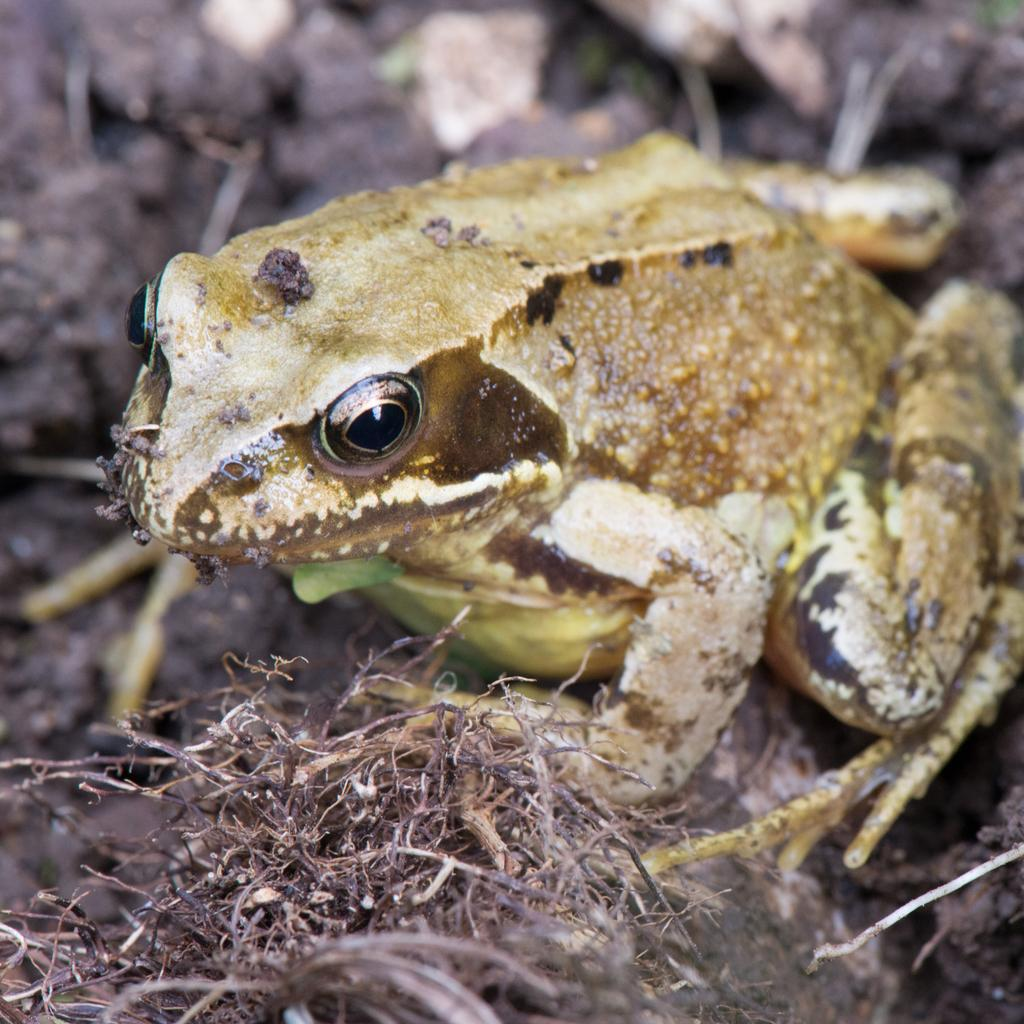What animal is present in the image? There is a frog in the image. Where is the frog located? The frog is on the ground. What type of vegetation can be seen in the image? There is dried grass in the image. Can you describe the background of the image? The background of the image is blurry. What is the ghost's reaction to the frog in the image? There is no ghost present in the image, so it is not possible to determine the ghost's reaction. 